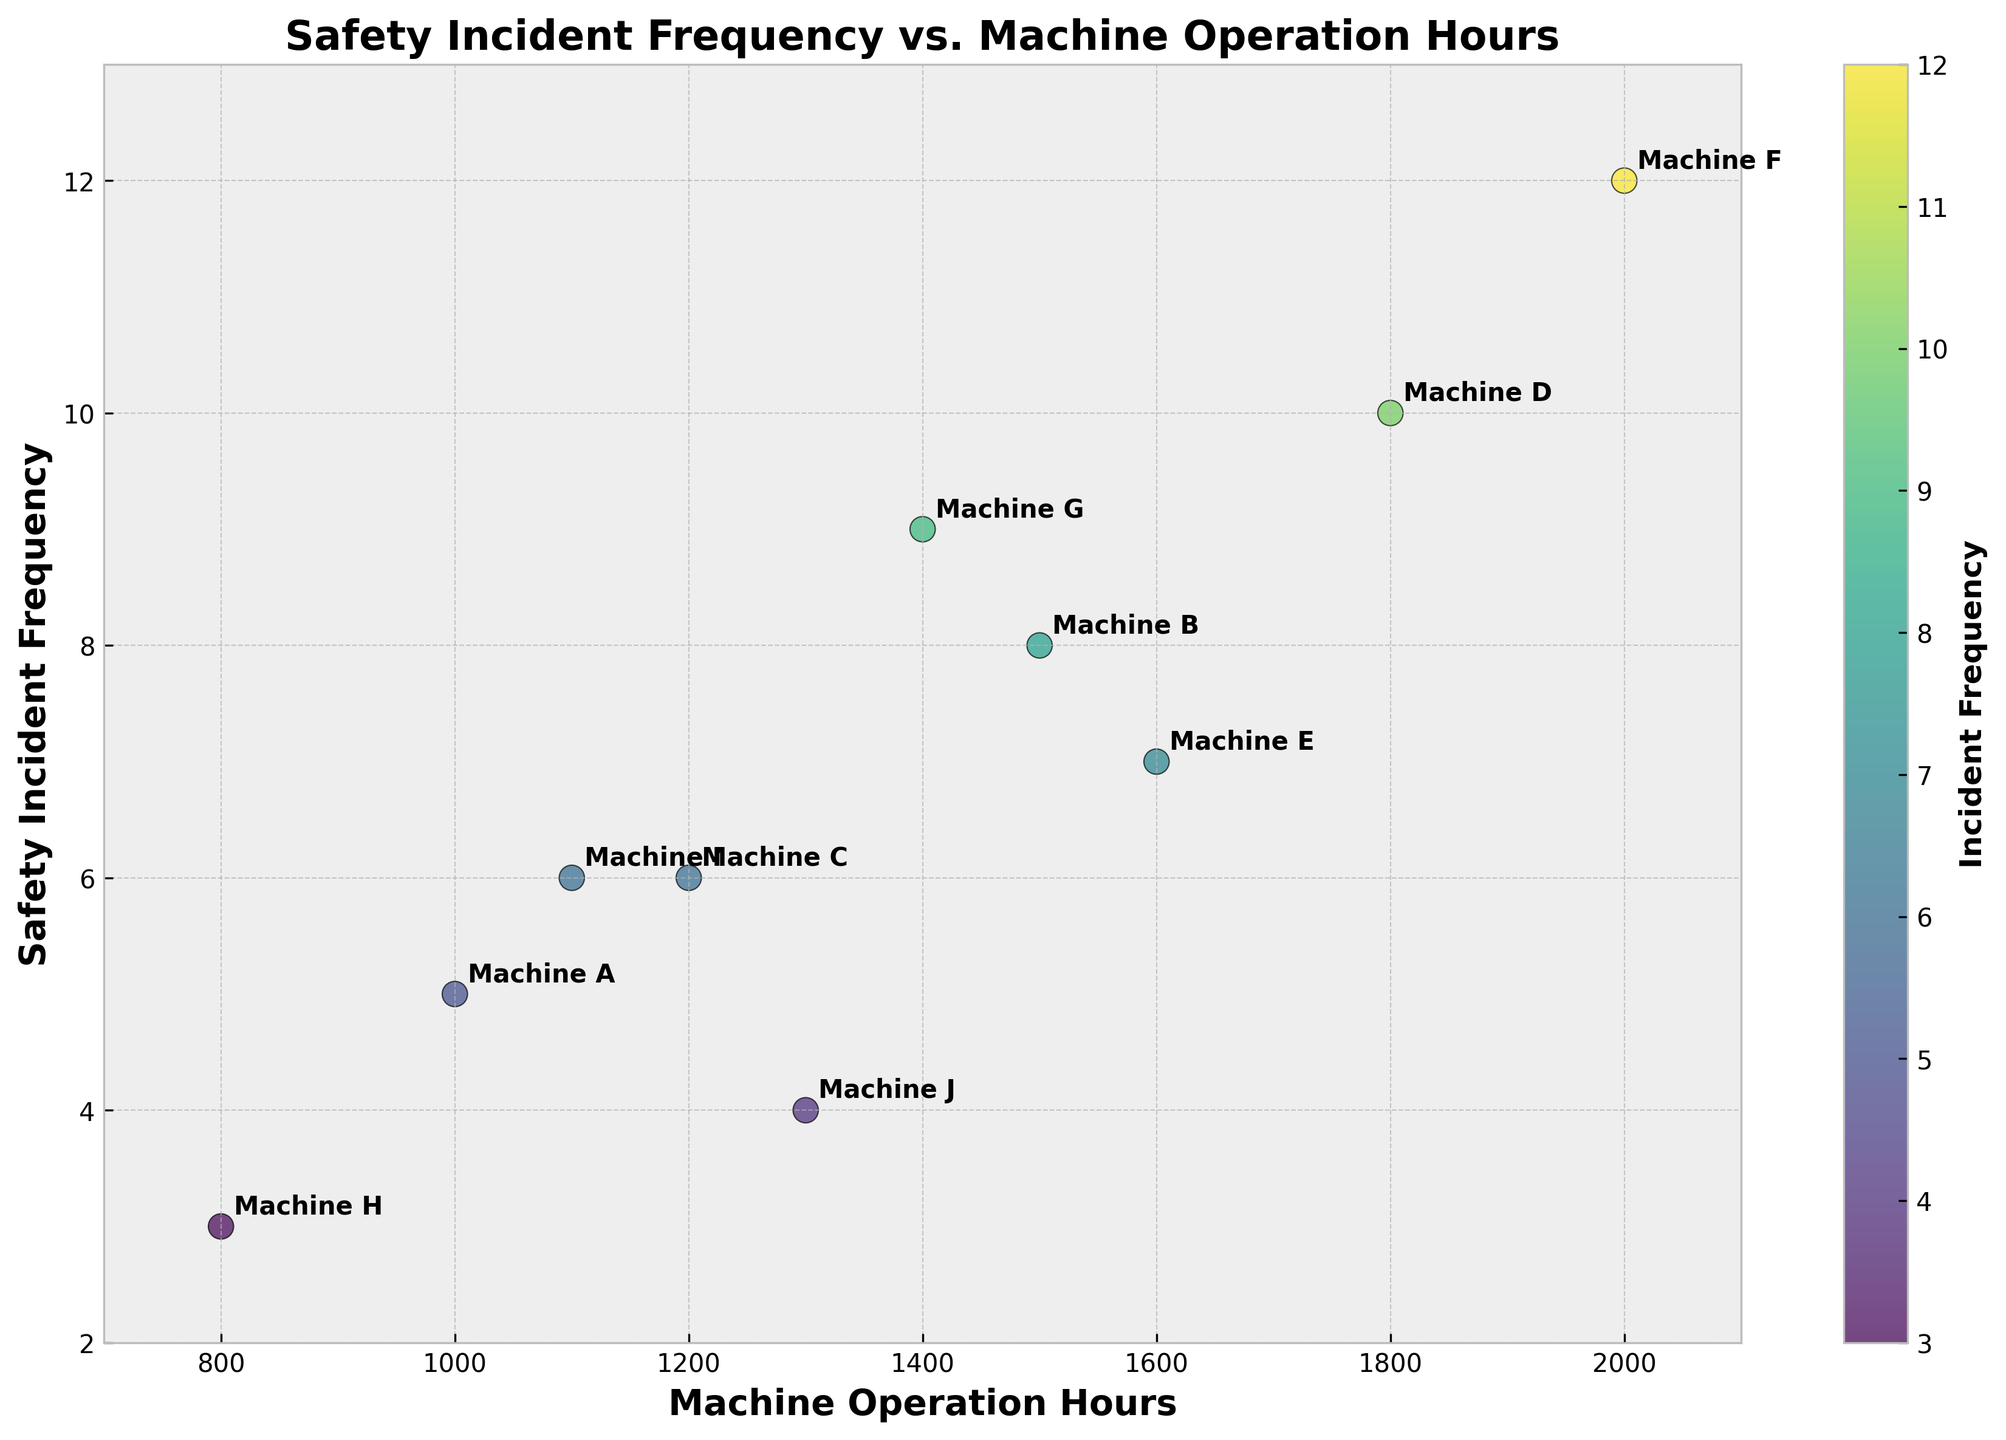What is the title of the scatter plot? The title is displayed at the top of the plot and summarizes the main subject of the plot.
Answer: Safety Incident Frequency vs. Machine Operation Hours How many data points are shown in the scatter plot? Count the number of unique points or labels annotated on the scatter plot. There should be one data point for each machine label.
Answer: 10 Which machine has the highest safety incident frequency? Identify the machine label associated with the highest point on the y-axis (Incident Frequency).
Answer: Machine F How many machines have an incident frequency greater than 6? Count the data points above the y-axis value of 6. Machines B, D, E, F, and G have frequencies above 6.
Answer: 5 What is the value of Operation Hours for Machine H, and how does it compare to Machine D's Operation Hours? Locate the points for Machine H and Machine D. Check the x-axis values for each and compare. Machine H is at 800 hours, and Machine D is at 1800 hours.
Answer: Machine H: 800, Machine D: 1800 Which machine has the closest incident frequency to Machine A? Find Machine A on the plot (Incident Frequency = 5) and identify the machine with the closest y-axis value to 5. Machine J has a frequency of 4 and is closest.
Answer: Machine J What is the average safety incident frequency for all machines? Sum the incident frequencies of all machines and divide by the number of machines. (5+8+6+10+7+12+9+3+6+4) / 10 = 70 / 10 = 7
Answer: 7 Which machine has the highest operation hours, and what is its incident frequency? Identify the point farthest to the right on the x-axis and read its y-axis value. Machine F has the highest Operation Hours at 2000 with an Incident Frequency of 12.
Answer: Machine F, 12 Is there a general trend visible between operation hours and safety incident frequency? Look for any apparent pattern or relationship between the positions of the points on the scatter plot. There's a positive trend where higher operation hours correlate with higher incident frequencies.
Answer: Positive correlation Between Machine E and Machine G, which has a higher incident frequency, and by how much? Identify the points for Machine E and G. Compare their y-axis values and calculate the difference. Machine E has an Incident Frequency of 7, and Machine G has 9. The difference is 9 - 7 = 2.
Answer: Machine G, by 2 